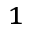<formula> <loc_0><loc_0><loc_500><loc_500>^ { 1 }</formula> 